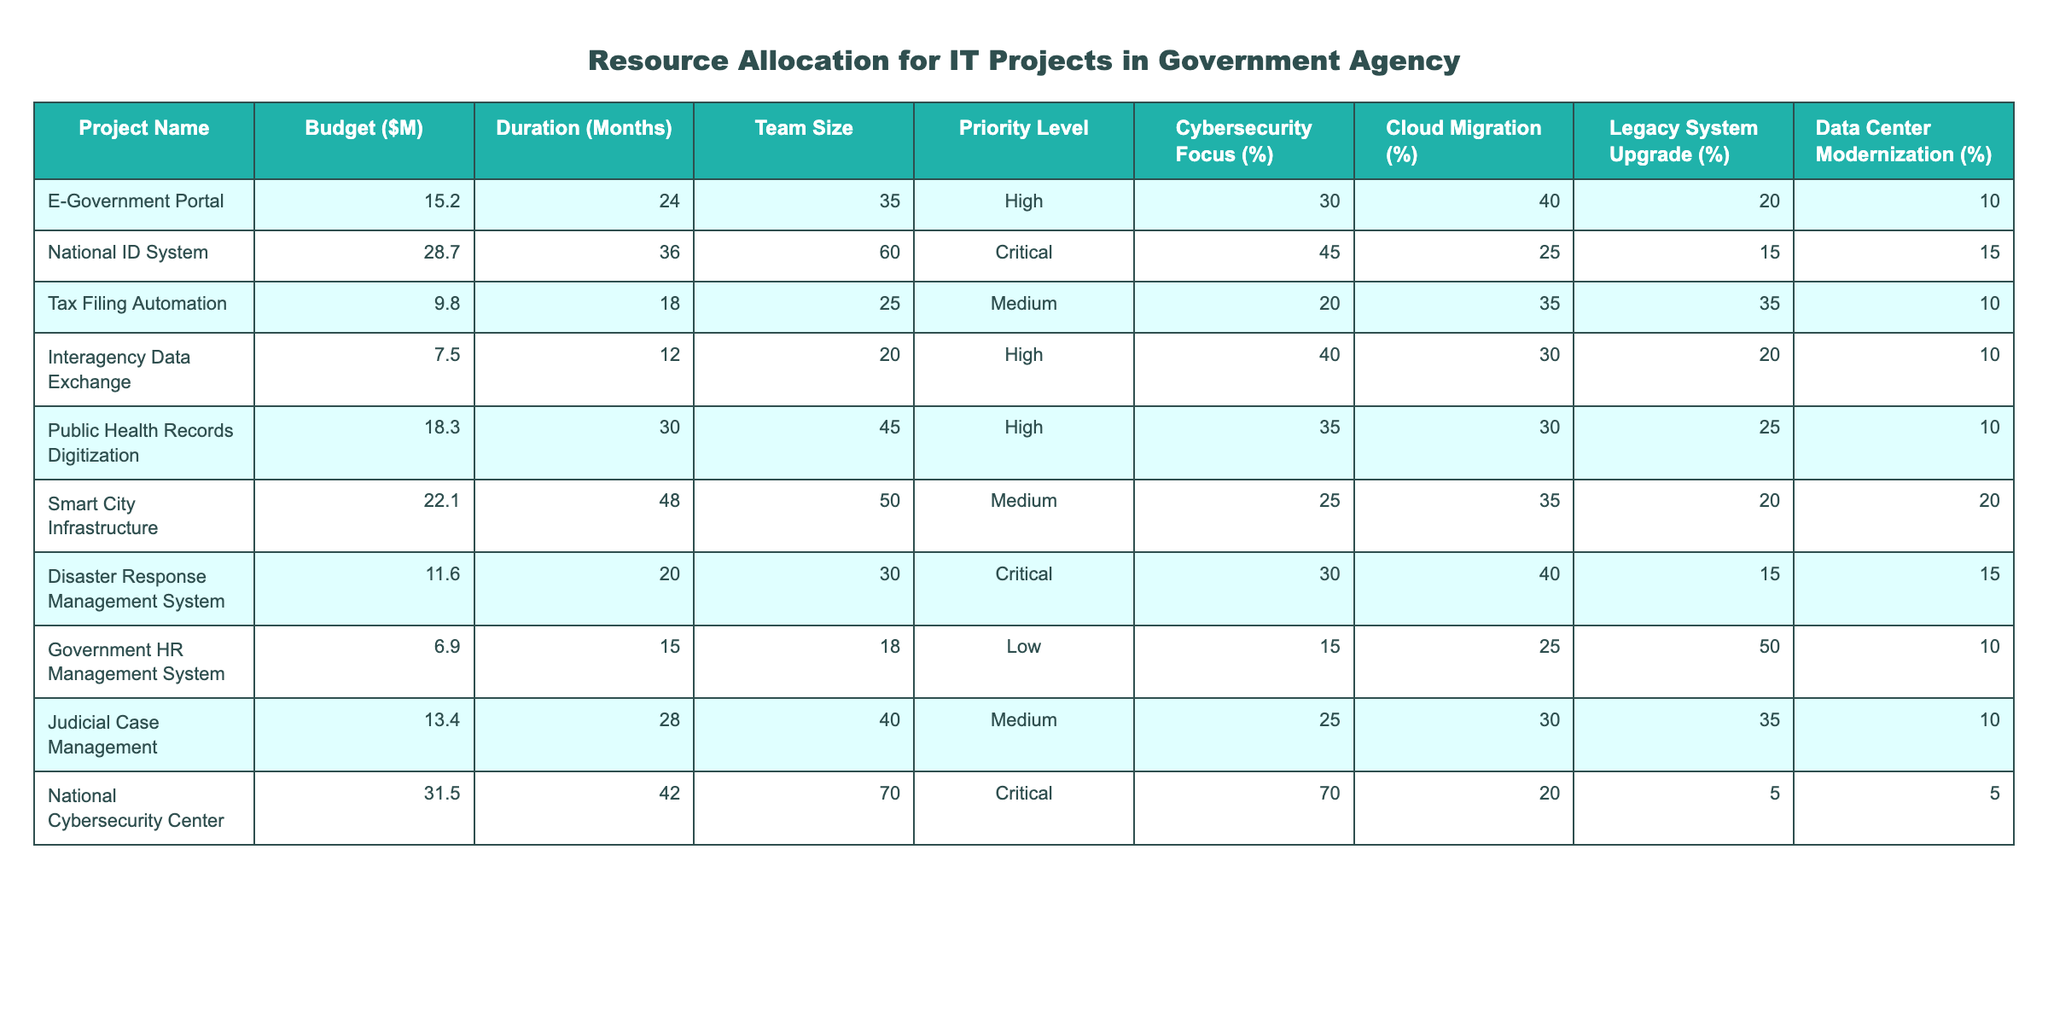What is the budget for the National ID System? The table directly lists the budget for the National ID System as $28.7 million.
Answer: $28.7 million How long is the duration of the Smart City Infrastructure project? The table shows the duration for the Smart City Infrastructure project as 48 months.
Answer: 48 months Which project has the highest priority level? The National Cybersecurity Center is marked as having the highest priority level, which is Critical.
Answer: National Cybersecurity Center What is the team size for the Public Health Records Digitization project? The table indicates that the team size for this project is 45.
Answer: 45 How many projects have a Cybersecurity Focus of 30% or more? The projects with a Cybersecurity Focus of 30% or more are: National ID System (45%), Public Health Records Digitization (35%), and National Cybersecurity Center (70%). That makes 3 projects.
Answer: 3 Calculate the average budget for all the projects listed. The total budget for all projects is $15.2M + $28.7M + $9.8M + $7.5M + $18.3M + $22.1M + $11.6M + $6.9M + $13.4M + $31.5M = $ 364.6 million. As there are 10 projects, the average budget is $364.6M / 10 = $36.46 million.
Answer: $36.46 million Is there any project with a Legacy System Upgrade focus of 50% or more? Yes, the Government HR Management System has a Legacy System Upgrade focus of 50%.
Answer: Yes What project has the most resources allocated in terms of budget and team size combined? The National Cybersecurity Center has the highest combined value, with a budget of $31.5 million and a team size of 70, totaling $101.5 million in resources. A few calculations might be needed: 31.5 + 70 = 101.5.
Answer: National Cybersecurity Center Which project has the lowest Cybersecurity Focus percentage? The Government HR Management System has the lowest Cybersecurity Focus percentage at 15%.
Answer: 15% What is the total duration of all projects that are classified as Critical? The Critical projects are the National ID System (36 months) and the National Cybersecurity Center (42 months), total duration is 36 + 42 = 78 months.
Answer: 78 months 